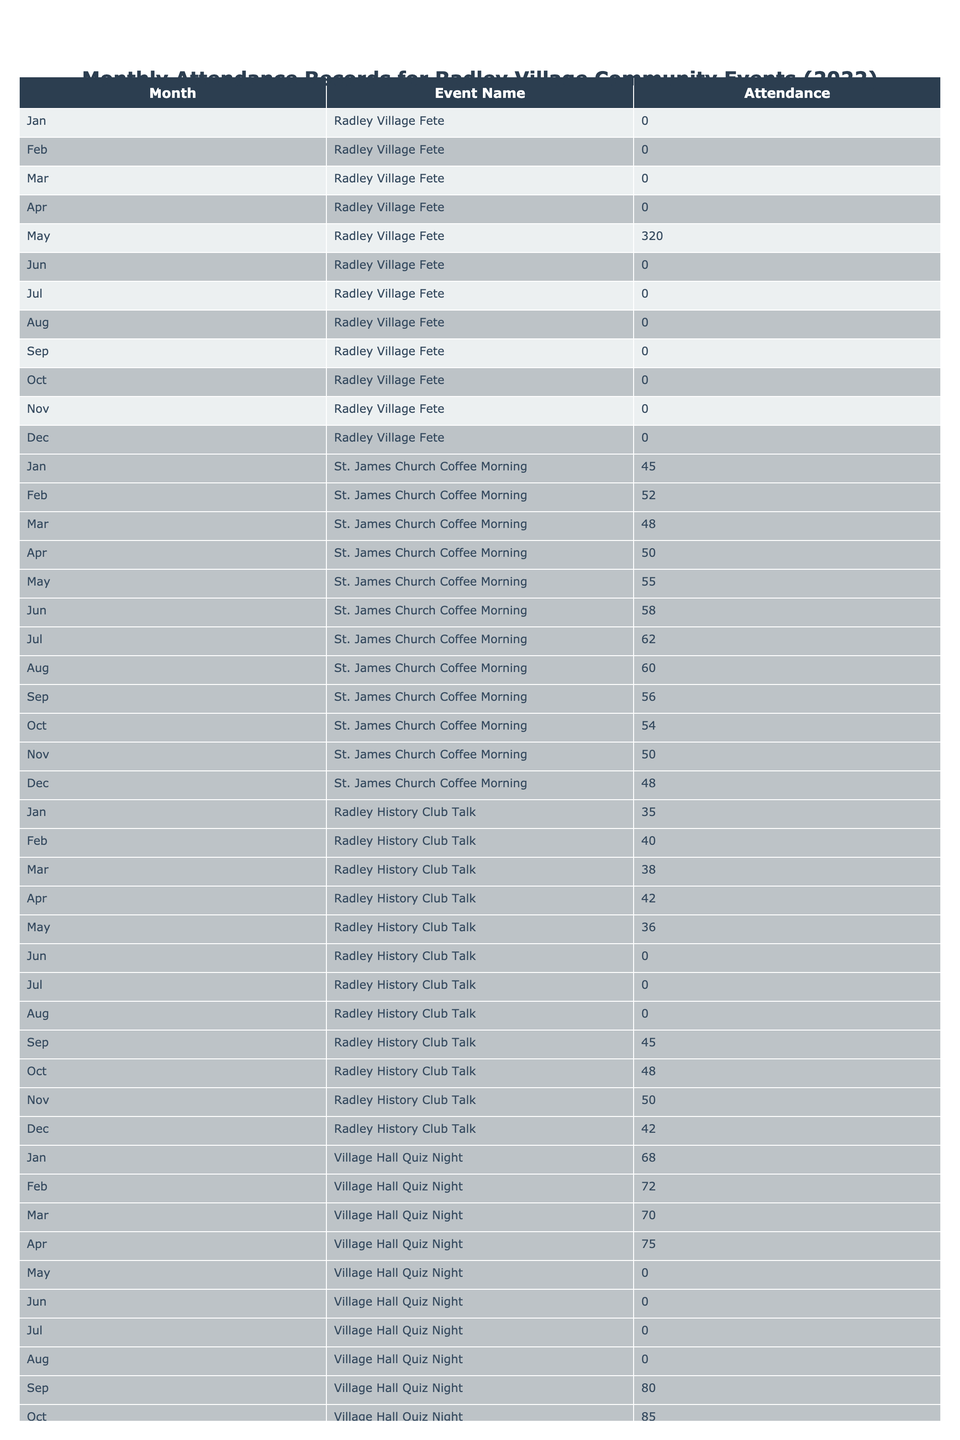What was the total attendance for the Radley Village Fete in 2022? The table shows that the attendance for the Radley Village Fete was only 320, and it occurred in May.
Answer: 320 How many attendees were present at the St. James Church Coffee Morning in March? According to the table, the attendance in March for this event was 48.
Answer: 48 Which event had the highest attendance in December? By checking the table, the Christmas Tree Lighting Ceremony had the highest attendance in December with 350 attendees.
Answer: 350 What is the total attendance for the Village Hall Quiz Night throughout the year? The monthly attendances for the Village Hall Quiz Night are 68, 72, 70, 75, 0, 0, 0, 0, 80, 85, 88, and 90. Summing these gives: 68 + 72 + 70 + 75 + 0 + 0 + 0 + 0 + 80 + 85 + 88 + 90 = 458.
Answer: 458 Was there any attendance for the Gooseacre Playing Fields Sports Day in February? The table indicates that the attendance for this event in February is 0, meaning there were no attendees.
Answer: No What month had the highest attendance for the Radley Youth Club Movie Night? Looking at the table, October had the highest attendance for this event with 64 attendees.
Answer: October How does the attendance at the Radley History Club Talk in September compare to that in April? The attendance in September is 45 while in April it's 42. Since 45 is greater than 42, the attendance in September is higher.
Answer: September is higher What was the average attendance for the Lower Radley Boat Club Regatta? The table shows attendance only for June, which was 180. Since there's only one month of data, the average is simply the same as the total: 180.
Answer: 180 Which event had the lowest total attendance for the year? Analyzing the total attendance of all events, the Radley College Open Day had its total as 330, and no other event had a lower total than this, such as the Radley Fete with only 320.
Answer: Radley Village Fete Can you list the events that had zero attendance during the month of July? According to the table, the events that had zero attendance in July are the Radley Village Fete, Radley College Open Day, Gooseacre Playing Fields Sports Day, and Radley History Club Talk.
Answer: Four events What was the difference in attendance between the Village Hall Quiz Night and the Radley Lakes Nature Walk in October? The table shows the Village Hall Quiz Night had 90 attendees, while the Radley Lakes Nature Walk had none (0) in October. The difference is 90 - 0 = 90.
Answer: 90 